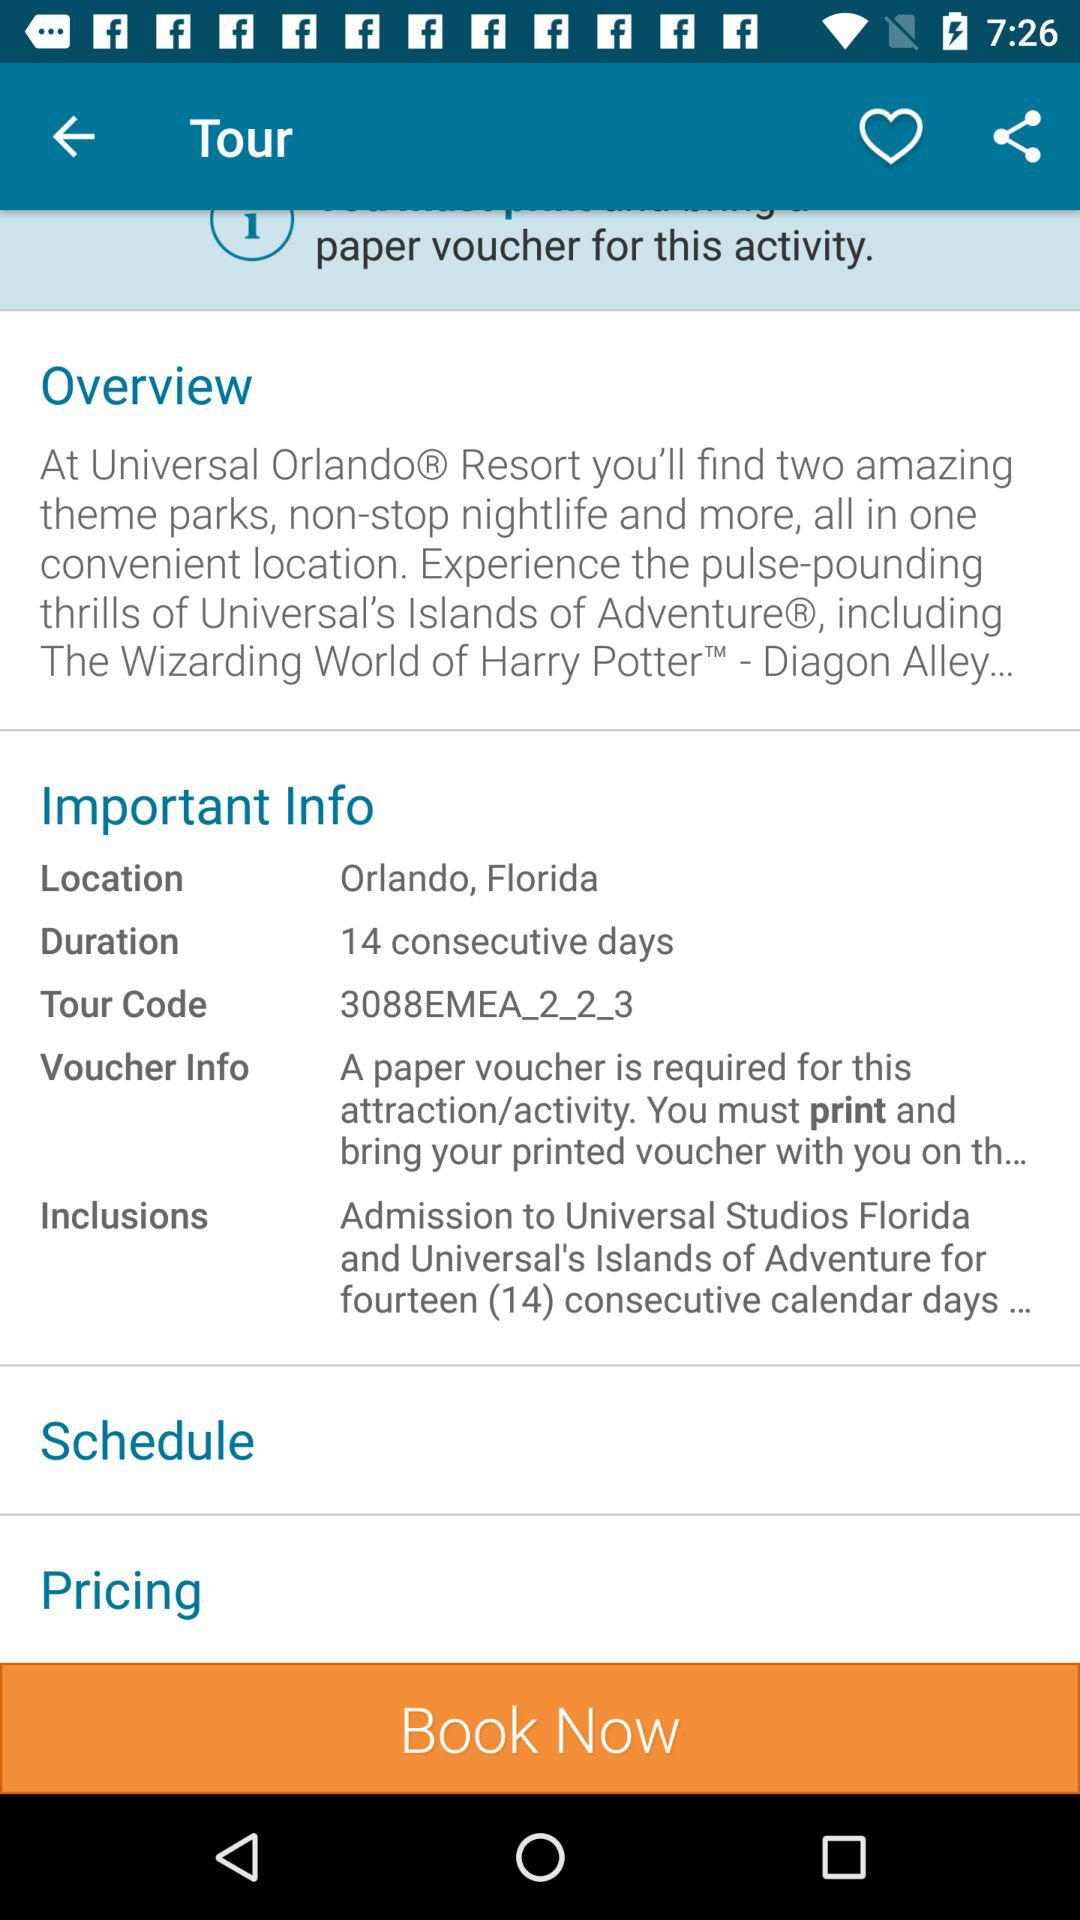What is the duration of this tour?
Answer the question using a single word or phrase. 14 consecutive days 